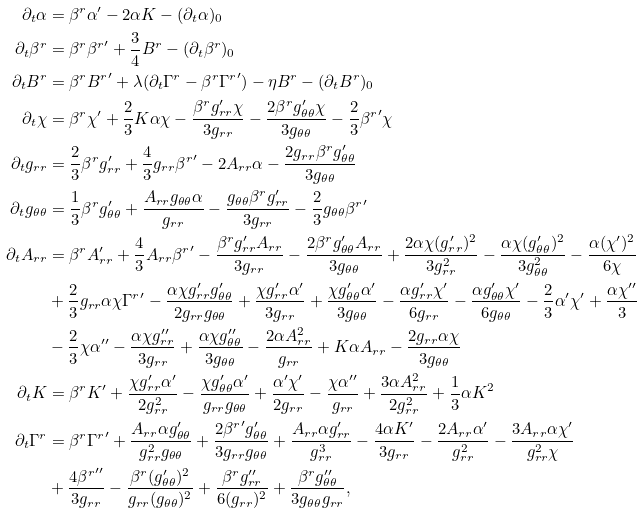<formula> <loc_0><loc_0><loc_500><loc_500>\partial _ { t } \alpha & = \beta ^ { r } \alpha ^ { \prime } - 2 \alpha K - ( \partial _ { t } \alpha ) _ { 0 } \\ \partial _ { t } \beta ^ { r } & = \beta ^ { r } { \beta ^ { r } } ^ { \prime } + \frac { 3 } { 4 } B ^ { r } - ( \partial _ { t } \beta ^ { r } ) _ { 0 } \\ \partial _ { t } B ^ { r } & = \beta ^ { r } { B ^ { r } } ^ { \prime } + \lambda ( \partial _ { t } \Gamma ^ { r } - \beta ^ { r } { \Gamma ^ { r } } ^ { \prime } ) - \eta B ^ { r } - ( \partial _ { t } B ^ { r } ) _ { 0 } \\ \partial _ { t } \chi & = \beta ^ { r } \chi ^ { \prime } + \frac { 2 } { 3 } K \alpha \chi - \frac { \beta ^ { r } g _ { r r } ^ { \prime } \chi } { 3 g _ { r r } } - \frac { 2 \beta ^ { r } g _ { \theta \theta } ^ { \prime } \chi } { 3 g _ { \theta \theta } } - \frac { 2 } { 3 } { \beta ^ { r } } ^ { \prime } \chi \\ \partial _ { t } g _ { r r } & = \frac { 2 } { 3 } \beta ^ { r } g _ { r r } ^ { \prime } + \frac { 4 } { 3 } g _ { r r } { \beta ^ { r } } ^ { \prime } - 2 A _ { r r } \alpha - \frac { 2 g _ { r r } \beta ^ { r } g _ { \theta \theta } ^ { \prime } } { 3 g _ { \theta \theta } } \\ \partial _ { t } g _ { \theta \theta } & = \frac { 1 } { 3 } \beta ^ { r } g _ { \theta \theta } ^ { \prime } + \frac { A _ { r r } g _ { \theta \theta } \alpha } { g _ { r r } } - \frac { g _ { \theta \theta } \beta ^ { r } g _ { r r } ^ { \prime } } { 3 g _ { r r } } - \frac { 2 } { 3 } g _ { \theta \theta } { \beta ^ { r } } ^ { \prime } \\ \partial _ { t } A _ { r r } & = \beta ^ { r } A _ { r r } ^ { \prime } + \frac { 4 } { 3 } A _ { r r } { \beta ^ { r } } ^ { \prime } - \frac { \beta ^ { r } g _ { r r } ^ { \prime } A _ { r r } } { 3 g _ { r r } } - \frac { 2 \beta ^ { r } g _ { \theta \theta } ^ { \prime } A _ { r r } } { 3 g _ { \theta \theta } } + \frac { 2 \alpha \chi ( g _ { r r } ^ { \prime } ) ^ { 2 } } { 3 g _ { r r } ^ { 2 } } - \frac { \alpha \chi ( g _ { \theta \theta } ^ { \prime } ) ^ { 2 } } { 3 g _ { \theta \theta } ^ { 2 } } - \frac { \alpha ( \chi ^ { \prime } ) ^ { 2 } } { 6 \chi } \\ & + \frac { 2 } { 3 } g _ { r r } \alpha \chi { \Gamma ^ { r } } ^ { \prime } - \frac { \alpha \chi g _ { r r } ^ { \prime } g _ { \theta \theta } ^ { \prime } } { 2 g _ { r r } g _ { \theta \theta } } + \frac { \chi g _ { r r } ^ { \prime } \alpha ^ { \prime } } { 3 g _ { r r } } + \frac { \chi g _ { \theta \theta } ^ { \prime } \alpha ^ { \prime } } { 3 g _ { \theta \theta } } - \frac { \alpha g _ { r r } ^ { \prime } \chi ^ { \prime } } { 6 g _ { r r } } - \frac { \alpha g _ { \theta \theta } ^ { \prime } \chi ^ { \prime } } { 6 g _ { \theta \theta } } - \frac { 2 } { 3 } \alpha ^ { \prime } \chi ^ { \prime } + \frac { \alpha \chi ^ { \prime \prime } } { 3 } \\ & - \frac { 2 } { 3 } \chi \alpha ^ { \prime \prime } - \frac { \alpha \chi g _ { r r } ^ { \prime \prime } } { 3 g _ { r r } } + \frac { \alpha \chi g _ { \theta \theta } ^ { \prime \prime } } { 3 g _ { \theta \theta } } - \frac { 2 \alpha A _ { r r } ^ { 2 } } { g _ { r r } } + K \alpha A _ { r r } - \frac { 2 g _ { r r } \alpha \chi } { 3 g _ { \theta \theta } } \\ \partial _ { t } K & = \beta ^ { r } K ^ { \prime } + \frac { \chi g _ { r r } ^ { \prime } \alpha ^ { \prime } } { 2 g _ { r r } ^ { 2 } } - \frac { \chi g _ { \theta \theta } ^ { \prime } \alpha ^ { \prime } } { g _ { r r } g _ { \theta \theta } } + \frac { \alpha ^ { \prime } \chi ^ { \prime } } { 2 g _ { r r } } - \frac { \chi \alpha ^ { \prime \prime } } { g _ { r r } } + \frac { 3 \alpha A _ { r r } ^ { 2 } } { 2 g _ { r r } ^ { 2 } } + \frac { 1 } { 3 } \alpha K ^ { 2 } \\ \partial _ { t } \Gamma ^ { r } & = \beta ^ { r } { \Gamma ^ { r } } ^ { \prime } + \frac { A _ { r r } \alpha g _ { \theta \theta } ^ { \prime } } { g _ { r r } ^ { 2 } g _ { \theta \theta } } + \frac { 2 { \beta ^ { r } } ^ { \prime } g _ { \theta \theta } ^ { \prime } } { 3 g _ { r r } g _ { \theta \theta } } + \frac { A _ { r r } \alpha g _ { r r } ^ { \prime } } { g _ { r r } ^ { 3 } } - \frac { 4 \alpha K ^ { \prime } } { 3 g _ { r r } } - \frac { 2 A _ { r r } \alpha ^ { \prime } } { g _ { r r } ^ { 2 } } - \frac { 3 A _ { r r } \alpha \chi ^ { \prime } } { g _ { r r } ^ { 2 } \chi } \\ & + \frac { 4 { \beta ^ { r } } ^ { \prime \prime } } { 3 g _ { r r } } - \frac { \beta ^ { r } ( g _ { \theta \theta } ^ { \prime } ) ^ { 2 } } { g _ { r r } ( g _ { \theta \theta } ) ^ { 2 } } + \frac { \beta ^ { r } g _ { r r } ^ { \prime \prime } } { 6 ( g _ { r r } ) ^ { 2 } } + \frac { \beta ^ { r } g _ { \theta \theta } ^ { \prime \prime } } { 3 g _ { \theta \theta } g _ { r r } } ,</formula> 